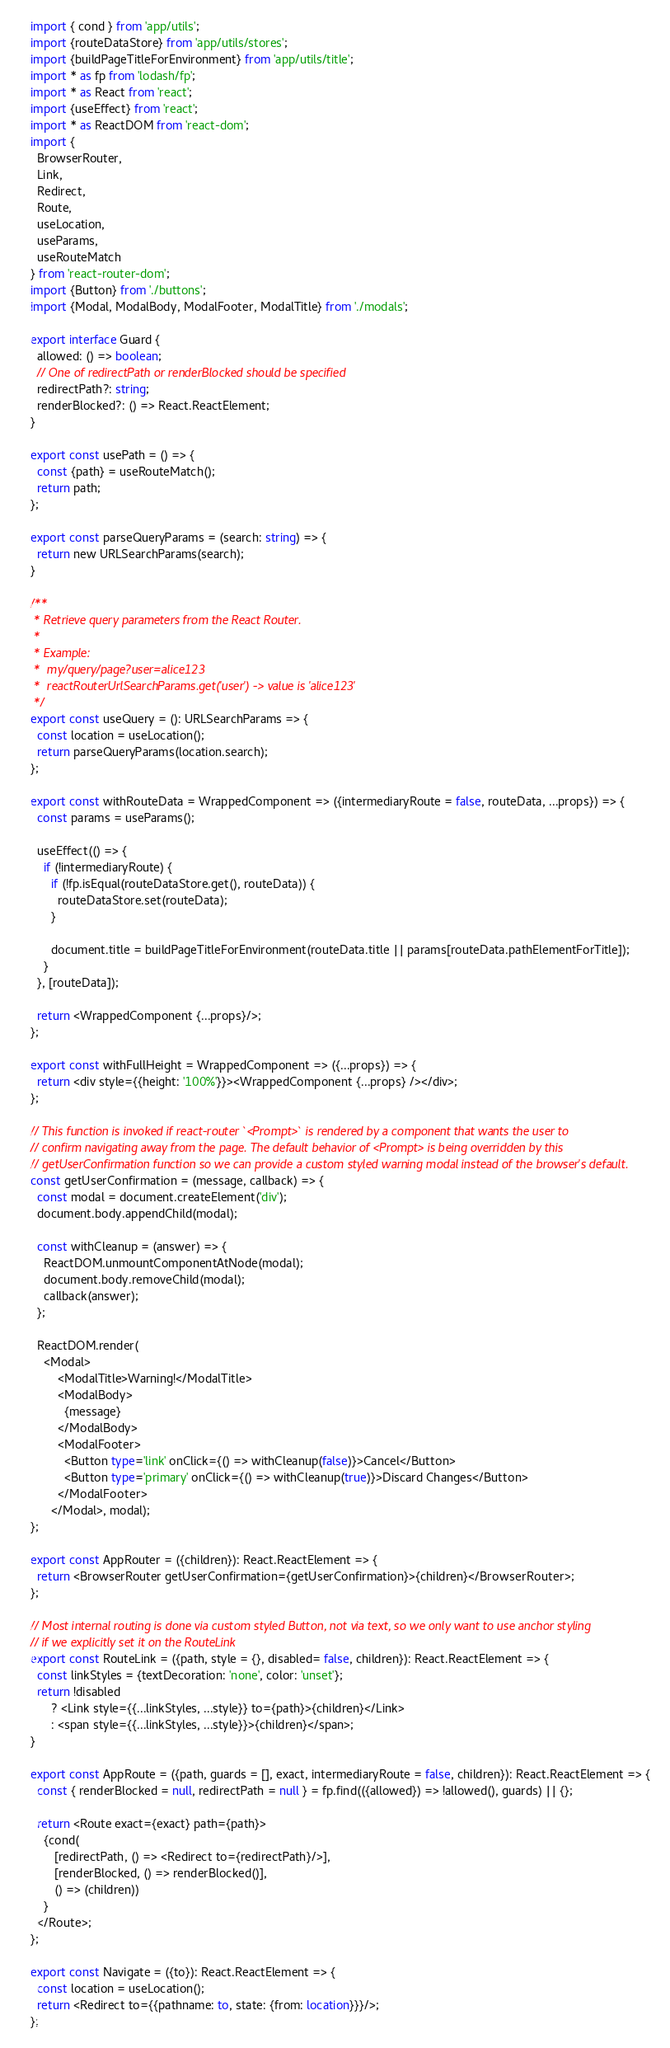Convert code to text. <code><loc_0><loc_0><loc_500><loc_500><_TypeScript_>import { cond } from 'app/utils';
import {routeDataStore} from 'app/utils/stores';
import {buildPageTitleForEnvironment} from 'app/utils/title';
import * as fp from 'lodash/fp';
import * as React from 'react';
import {useEffect} from 'react';
import * as ReactDOM from 'react-dom';
import {
  BrowserRouter,
  Link,
  Redirect,
  Route,
  useLocation,
  useParams,
  useRouteMatch
} from 'react-router-dom';
import {Button} from './buttons';
import {Modal, ModalBody, ModalFooter, ModalTitle} from './modals';

export interface Guard {
  allowed: () => boolean;
  // One of redirectPath or renderBlocked should be specified
  redirectPath?: string;
  renderBlocked?: () => React.ReactElement;
}

export const usePath = () => {
  const {path} = useRouteMatch();
  return path;
};

export const parseQueryParams = (search: string) => {
  return new URLSearchParams(search);
}

/**
 * Retrieve query parameters from the React Router.
 *
 * Example:
 *  my/query/page?user=alice123
 *  reactRouterUrlSearchParams.get('user') -> value is 'alice123'
 */
export const useQuery = (): URLSearchParams => {
  const location = useLocation();
  return parseQueryParams(location.search);
};

export const withRouteData = WrappedComponent => ({intermediaryRoute = false, routeData, ...props}) => {
  const params = useParams();

  useEffect(() => {
    if (!intermediaryRoute) {
      if (!fp.isEqual(routeDataStore.get(), routeData)) {
        routeDataStore.set(routeData);
      }

      document.title = buildPageTitleForEnvironment(routeData.title || params[routeData.pathElementForTitle]);
    }
  }, [routeData]);

  return <WrappedComponent {...props}/>;
};

export const withFullHeight = WrappedComponent => ({...props}) => {
  return <div style={{height: '100%'}}><WrappedComponent {...props} /></div>;
};

// This function is invoked if react-router `<Prompt>` is rendered by a component that wants the user to
// confirm navigating away from the page. The default behavior of <Prompt> is being overridden by this
// getUserConfirmation function so we can provide a custom styled warning modal instead of the browser's default.
const getUserConfirmation = (message, callback) => {
  const modal = document.createElement('div');
  document.body.appendChild(modal);

  const withCleanup = (answer) => {
    ReactDOM.unmountComponentAtNode(modal);
    document.body.removeChild(modal);
    callback(answer);
  };

  ReactDOM.render(
    <Modal>
        <ModalTitle>Warning!</ModalTitle>
        <ModalBody>
          {message}
        </ModalBody>
        <ModalFooter>
          <Button type='link' onClick={() => withCleanup(false)}>Cancel</Button>
          <Button type='primary' onClick={() => withCleanup(true)}>Discard Changes</Button>
        </ModalFooter>
      </Modal>, modal);
};

export const AppRouter = ({children}): React.ReactElement => {
  return <BrowserRouter getUserConfirmation={getUserConfirmation}>{children}</BrowserRouter>;
};

// Most internal routing is done via custom styled Button, not via text, so we only want to use anchor styling
// if we explicitly set it on the RouteLink
export const RouteLink = ({path, style = {}, disabled= false, children}): React.ReactElement => {
  const linkStyles = {textDecoration: 'none', color: 'unset'};
  return !disabled
      ? <Link style={{...linkStyles, ...style}} to={path}>{children}</Link>
      : <span style={{...linkStyles, ...style}}>{children}</span>;
}

export const AppRoute = ({path, guards = [], exact, intermediaryRoute = false, children}): React.ReactElement => {
  const { renderBlocked = null, redirectPath = null } = fp.find(({allowed}) => !allowed(), guards) || {};

  return <Route exact={exact} path={path}>
    {cond(
       [redirectPath, () => <Redirect to={redirectPath}/>],
       [renderBlocked, () => renderBlocked()],
       () => (children))
    }
  </Route>;
};

export const Navigate = ({to}): React.ReactElement => {
  const location = useLocation();
  return <Redirect to={{pathname: to, state: {from: location}}}/>;
};
</code> 